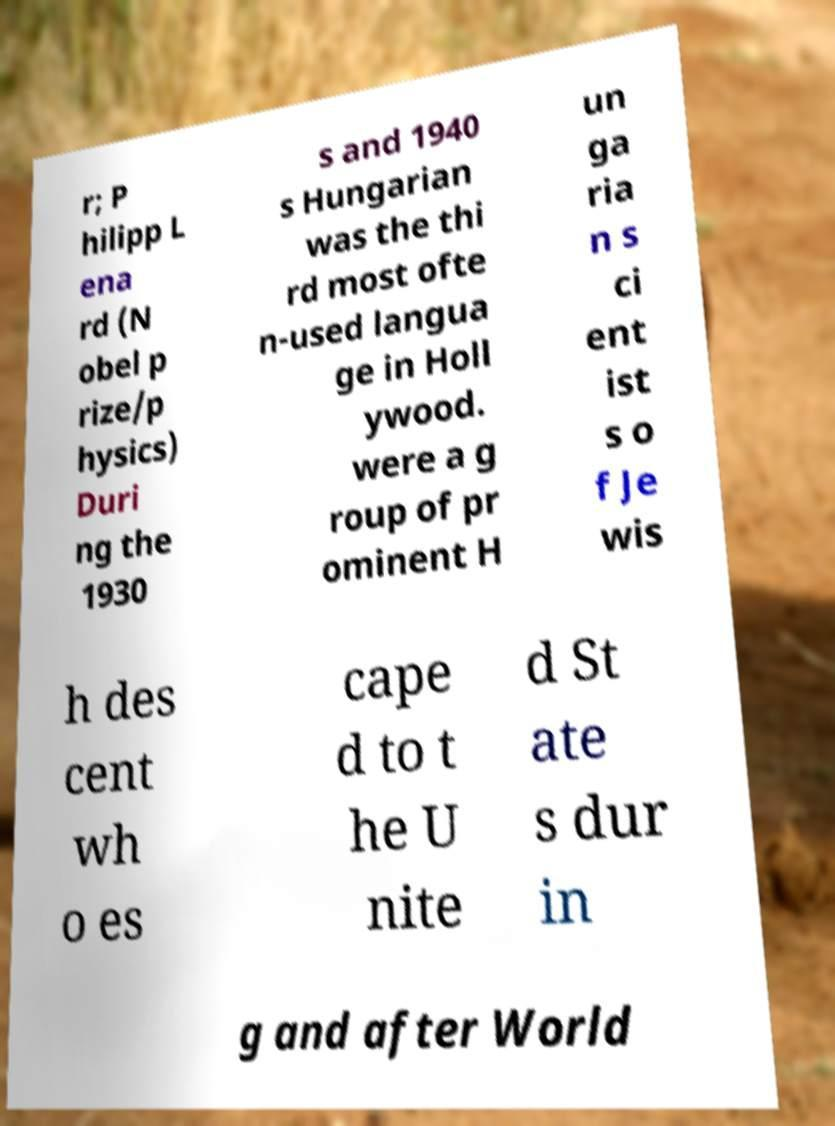Could you extract and type out the text from this image? r; P hilipp L ena rd (N obel p rize/p hysics) Duri ng the 1930 s and 1940 s Hungarian was the thi rd most ofte n-used langua ge in Holl ywood. were a g roup of pr ominent H un ga ria n s ci ent ist s o f Je wis h des cent wh o es cape d to t he U nite d St ate s dur in g and after World 